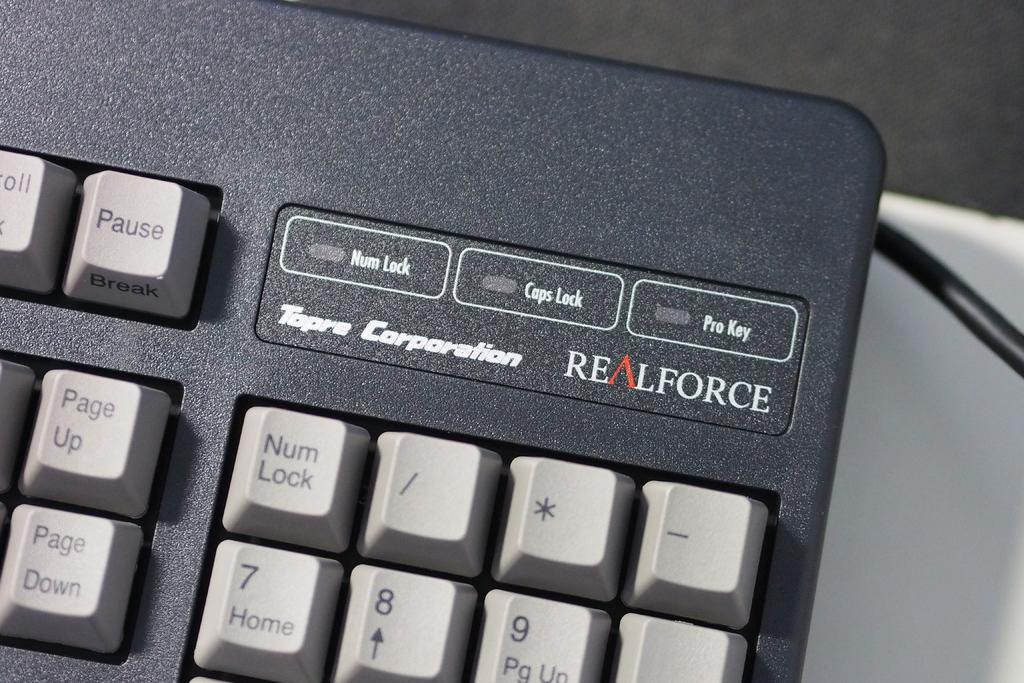<image>
Write a terse but informative summary of the picture. The keyboard shown in grey was made by Real Force. 